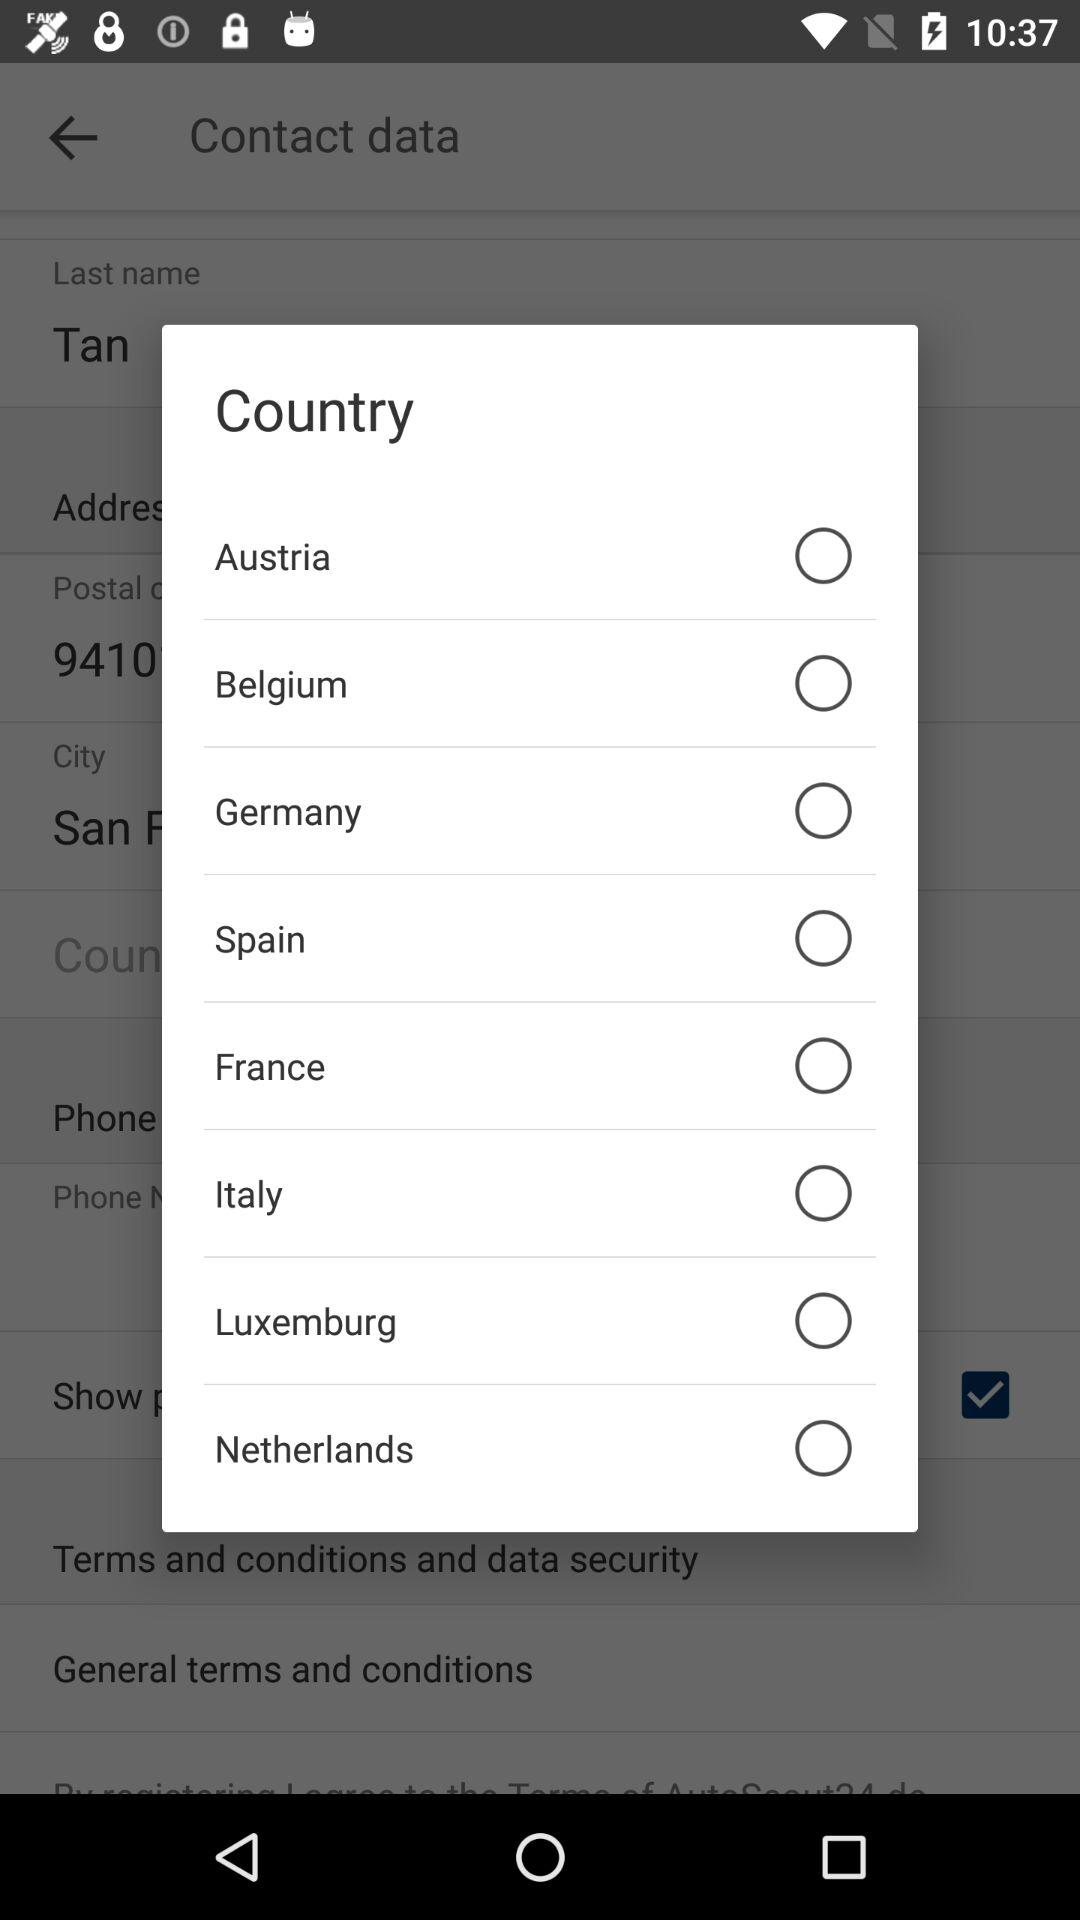How many countries are available to select from?
Answer the question using a single word or phrase. 8 